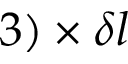<formula> <loc_0><loc_0><loc_500><loc_500>3 ) \times \delta l</formula> 